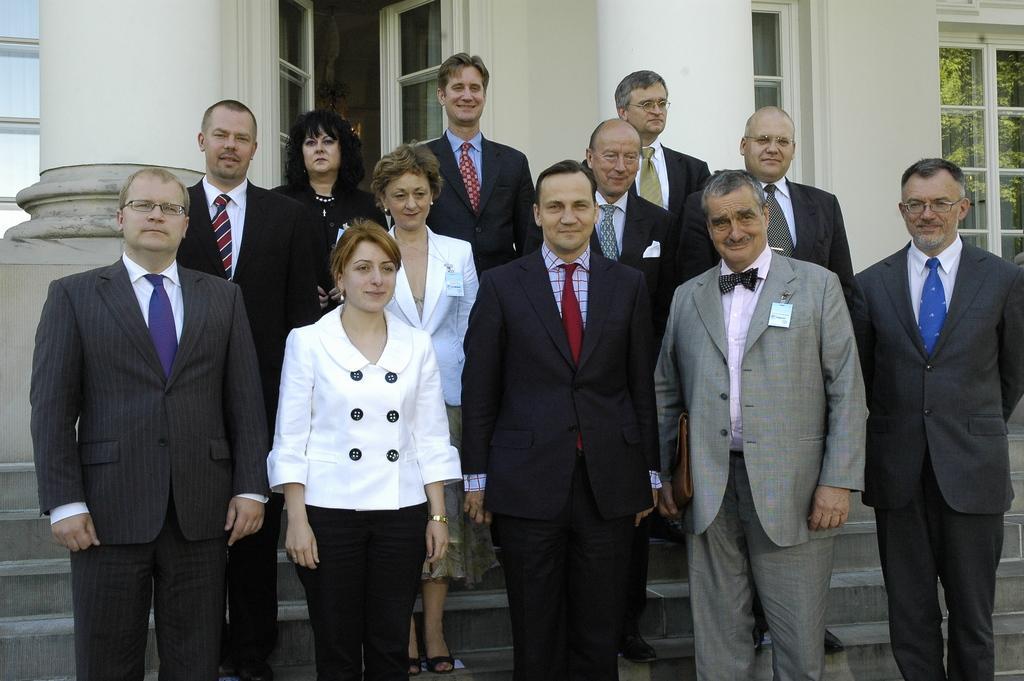Please provide a concise description of this image. In the image there are a group of people standing in front of a building and posing for the photo, behind them they are huge pillars and behind the pillars there are few windows and doors. 